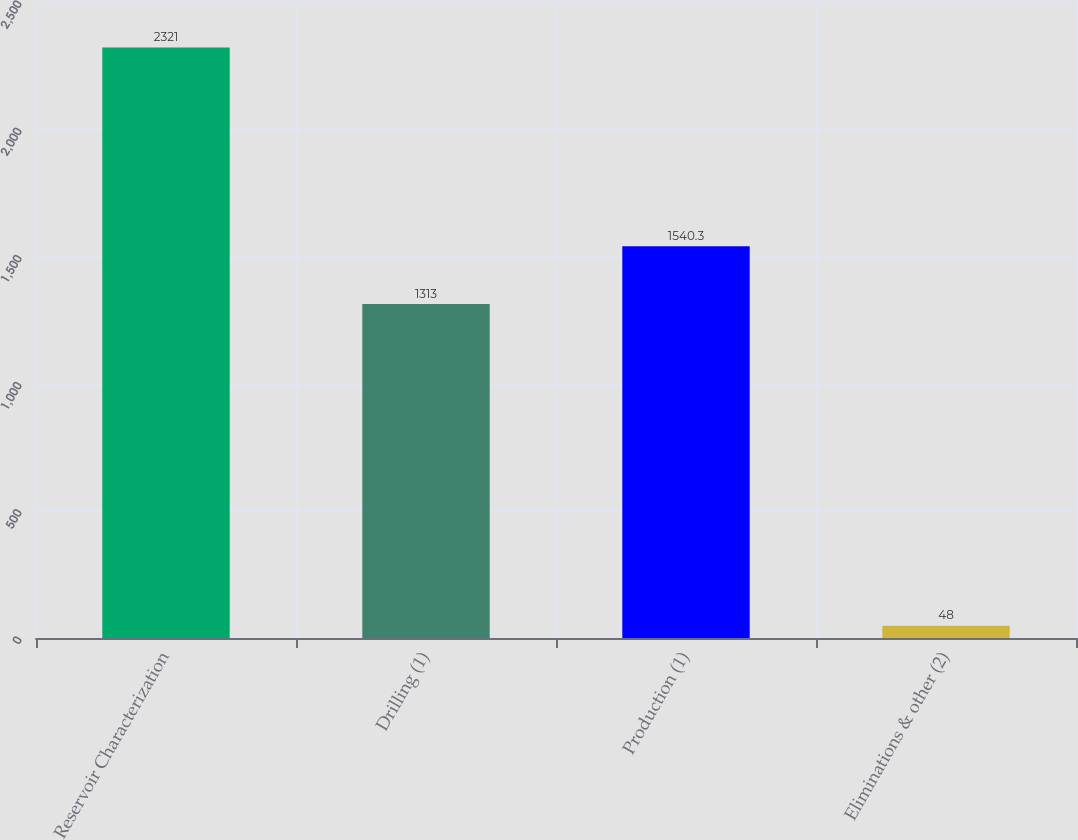Convert chart to OTSL. <chart><loc_0><loc_0><loc_500><loc_500><bar_chart><fcel>Reservoir Characterization<fcel>Drilling (1)<fcel>Production (1)<fcel>Eliminations & other (2)<nl><fcel>2321<fcel>1313<fcel>1540.3<fcel>48<nl></chart> 